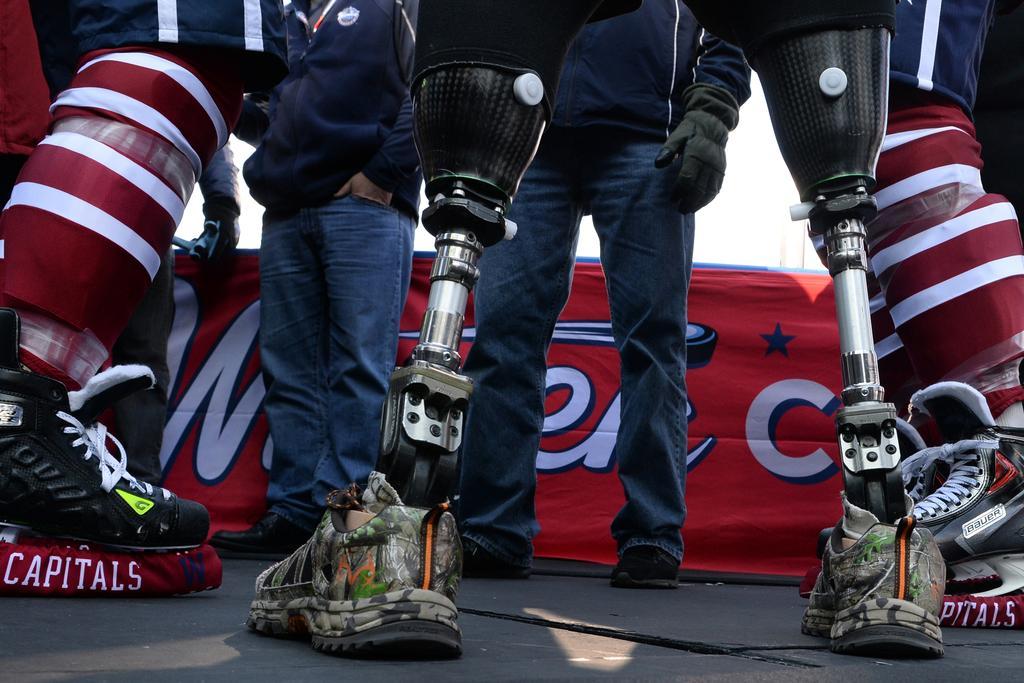Describe this image in one or two sentences. There is a person having artificial limbs and there are two other persons standing in front of him. 